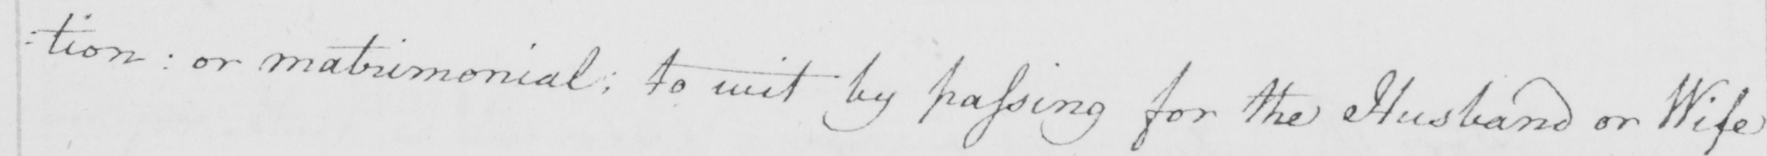Please provide the text content of this handwritten line. : tion :  or matrimonial ; to wit by passing for the Husband or Wife 